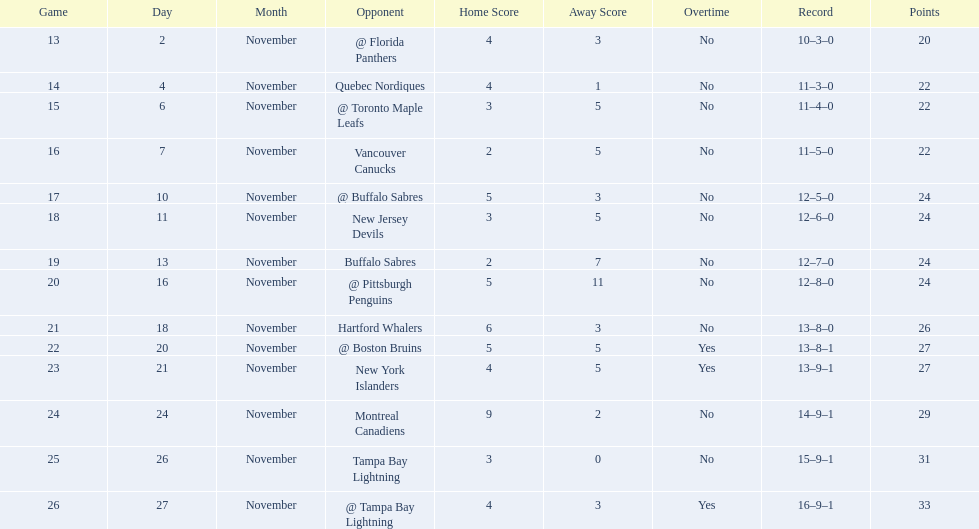What are the teams in the atlantic division? Quebec Nordiques, Vancouver Canucks, New Jersey Devils, Buffalo Sabres, Hartford Whalers, New York Islanders, Montreal Canadiens, Tampa Bay Lightning. Which of those scored fewer points than the philadelphia flyers? Tampa Bay Lightning. Can you parse all the data within this table? {'header': ['Game', 'Day', 'Month', 'Opponent', 'Home Score', 'Away Score', 'Overtime', 'Record', 'Points'], 'rows': [['13', '2', 'November', '@ Florida Panthers', '4', '3', 'No', '10–3–0', '20'], ['14', '4', 'November', 'Quebec Nordiques', '4', '1', 'No', '11–3–0', '22'], ['15', '6', 'November', '@ Toronto Maple Leafs', '3', '5', 'No', '11–4–0', '22'], ['16', '7', 'November', 'Vancouver Canucks', '2', '5', 'No', '11–5–0', '22'], ['17', '10', 'November', '@ Buffalo Sabres', '5', '3', 'No', '12–5–0', '24'], ['18', '11', 'November', 'New Jersey Devils', '3', '5', 'No', '12–6–0', '24'], ['19', '13', 'November', 'Buffalo Sabres', '2', '7', 'No', '12–7–0', '24'], ['20', '16', 'November', '@ Pittsburgh Penguins', '5', '11', 'No', '12–8–0', '24'], ['21', '18', 'November', 'Hartford Whalers', '6', '3', 'No', '13–8–0', '26'], ['22', '20', 'November', '@ Boston Bruins', '5', '5', 'Yes', '13–8–1', '27'], ['23', '21', 'November', 'New York Islanders', '4', '5', 'Yes', '13–9–1', '27'], ['24', '24', 'November', 'Montreal Canadiens', '9', '2', 'No', '14–9–1', '29'], ['25', '26', 'November', 'Tampa Bay Lightning', '3', '0', 'No', '15–9–1', '31'], ['26', '27', 'November', '@ Tampa Bay Lightning', '4', '3', 'Yes', '16–9–1', '33']]} 